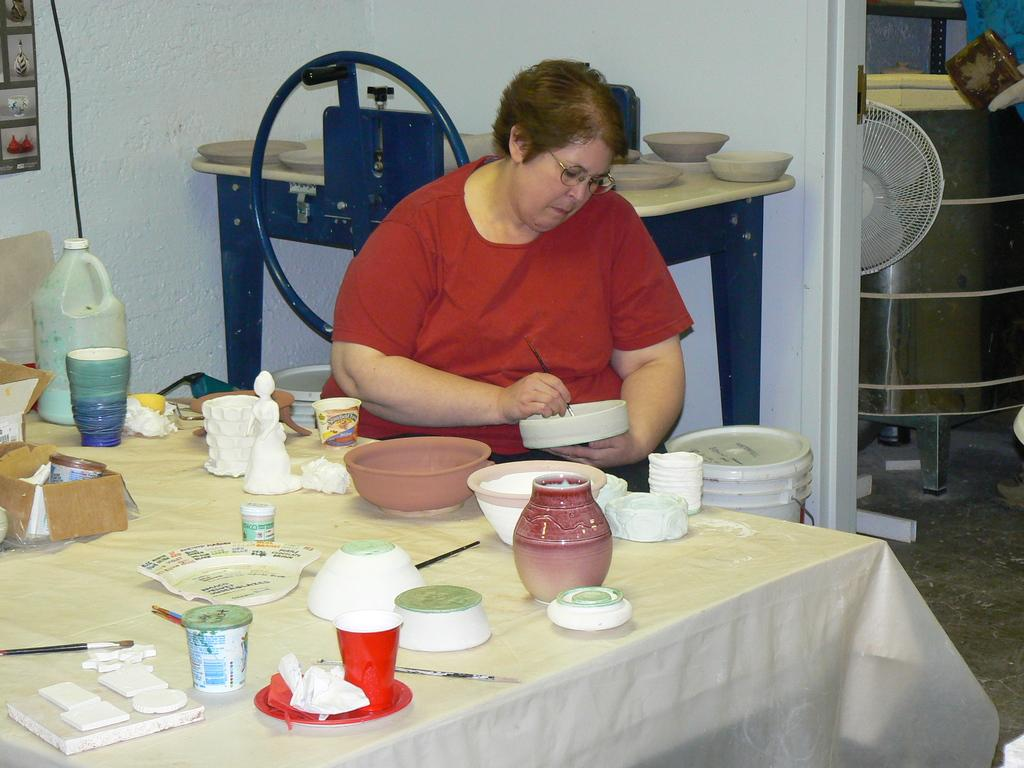Who is present in the image? There is a woman in the image. What is the woman doing in the image? The woman is sitting on a chair and holding a brush in her hands. What is in front of the woman? There is a table in front of the woman. What can be found on the table? There are bowls and other objects on the table. What is visible in the background of the image? There is a wall visible in the image. What type of meat is being served on a plate in the image? There is no plate or meat present in the image. Can you tell me how many pickles are on the table in the image? There is no mention of pickles in the image; only bowls and other objects are present on the table. 